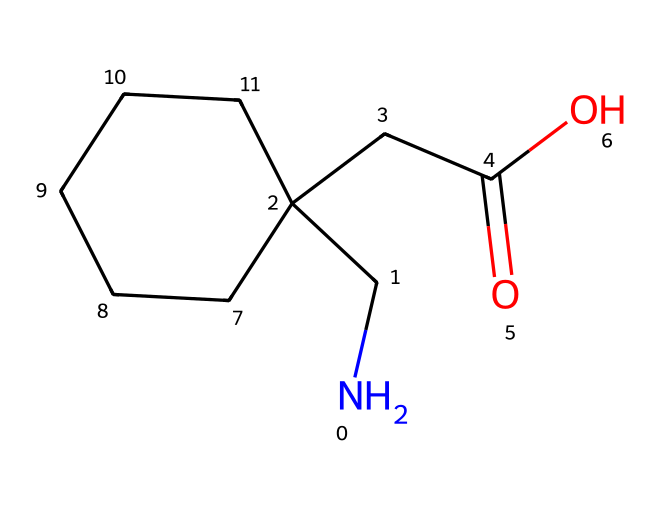What is the molecular formula of gabapentin based on the structure? To determine the molecular formula, count the number of each type of atom present in the structure. From the SMILES representation, there are 11 carbon atoms, 20 hydrogen atoms, and 2 nitrogen atoms, which constitutes the formula C11H20N2O2.
Answer: C11H20N2O2 How many rings are present in the structure of gabapentin? By examining the chemical structure, we see that there are no closed loops or circular formations, indicating that there are zero rings in this molecule.
Answer: 0 What is the functional group present in gabapentin? Looking at the structure, we can identify a carboxylic acid functional group (-COOH) due to the presence of a carbonyl (C=O) and a hydroxyl (-OH) group connected to the same carbon.
Answer: carboxylic acid Does gabapentin contain any nitrogen atoms? The structural representation shows that there are two nitrogen atoms present within the molecule, confirming that gabapentin does contain nitrogen.
Answer: yes Is gabapentin a linear molecule or a cyclic molecule? Upon reviewing the structure, it is clear that gabapentin has a branched form and does not form a closed loop, indicating that it is a linear molecule.
Answer: linear What type of drug classification does gabapentin fall under? Gabapentin is classified as an anticonvulsant and analgesic medication based on its structure and pharmacological actions in treating nerve pain and seizures.
Answer: anticonvulsant 